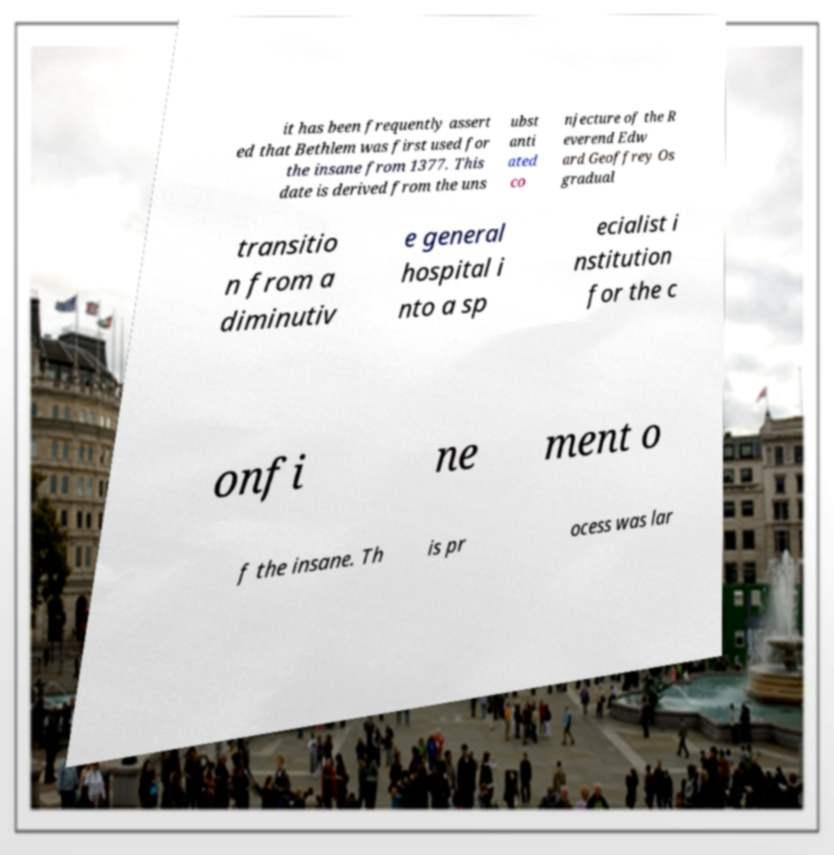Can you accurately transcribe the text from the provided image for me? it has been frequently assert ed that Bethlem was first used for the insane from 1377. This date is derived from the uns ubst anti ated co njecture of the R everend Edw ard Geoffrey Os gradual transitio n from a diminutiv e general hospital i nto a sp ecialist i nstitution for the c onfi ne ment o f the insane. Th is pr ocess was lar 